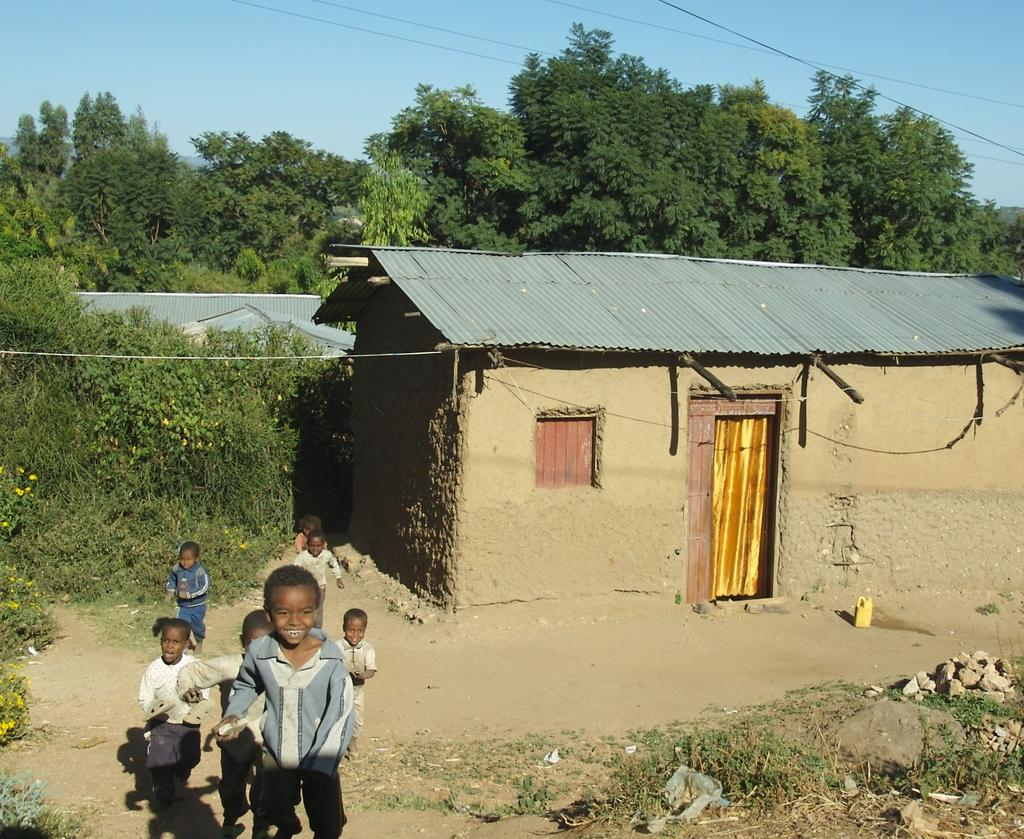Who is present in the image? There are children in the image. What type of structure can be seen in the image? There is a hut in the image. Can you describe the hut's features? The hut has a roof, a window, and a door. What is the color of the curtains on the door? The door has yellow curtains. What else can be seen in the image besides the hut and children? There are trees and wires in the image. Where is the shop located in the image? There is no shop present in the image. 